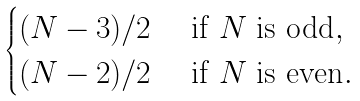Convert formula to latex. <formula><loc_0><loc_0><loc_500><loc_500>\begin{cases} ( N - 3 ) / 2 & \text { if $N$ is odd} , \\ ( N - 2 ) / 2 & \text { if $N$ is even} . \end{cases}</formula> 